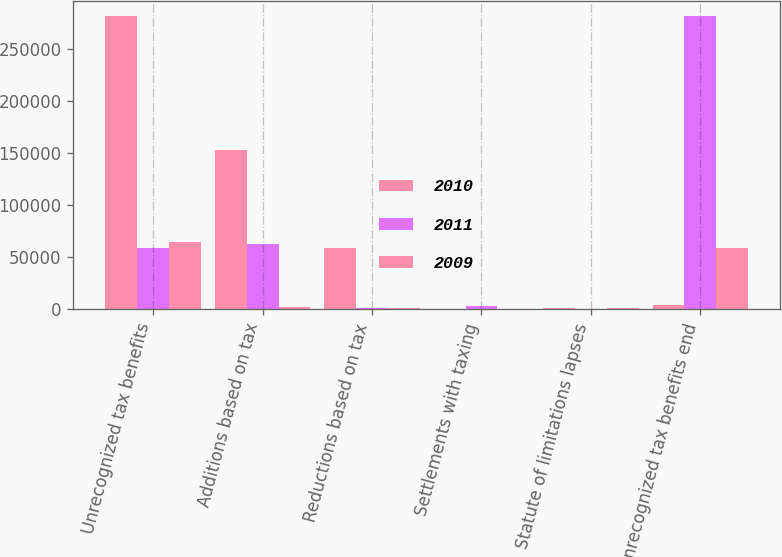<chart> <loc_0><loc_0><loc_500><loc_500><stacked_bar_chart><ecel><fcel>Unrecognized tax benefits<fcel>Additions based on tax<fcel>Reductions based on tax<fcel>Settlements with taxing<fcel>Statute of limitations lapses<fcel>Unrecognized tax benefits end<nl><fcel>2010<fcel>281666<fcel>152497<fcel>59315<fcel>422<fcel>1195<fcel>3811<nl><fcel>2011<fcel>58696<fcel>62752<fcel>1517<fcel>3448<fcel>651<fcel>281666<nl><fcel>2009<fcel>64655<fcel>2293<fcel>1229<fcel>681<fcel>966<fcel>58696<nl></chart> 